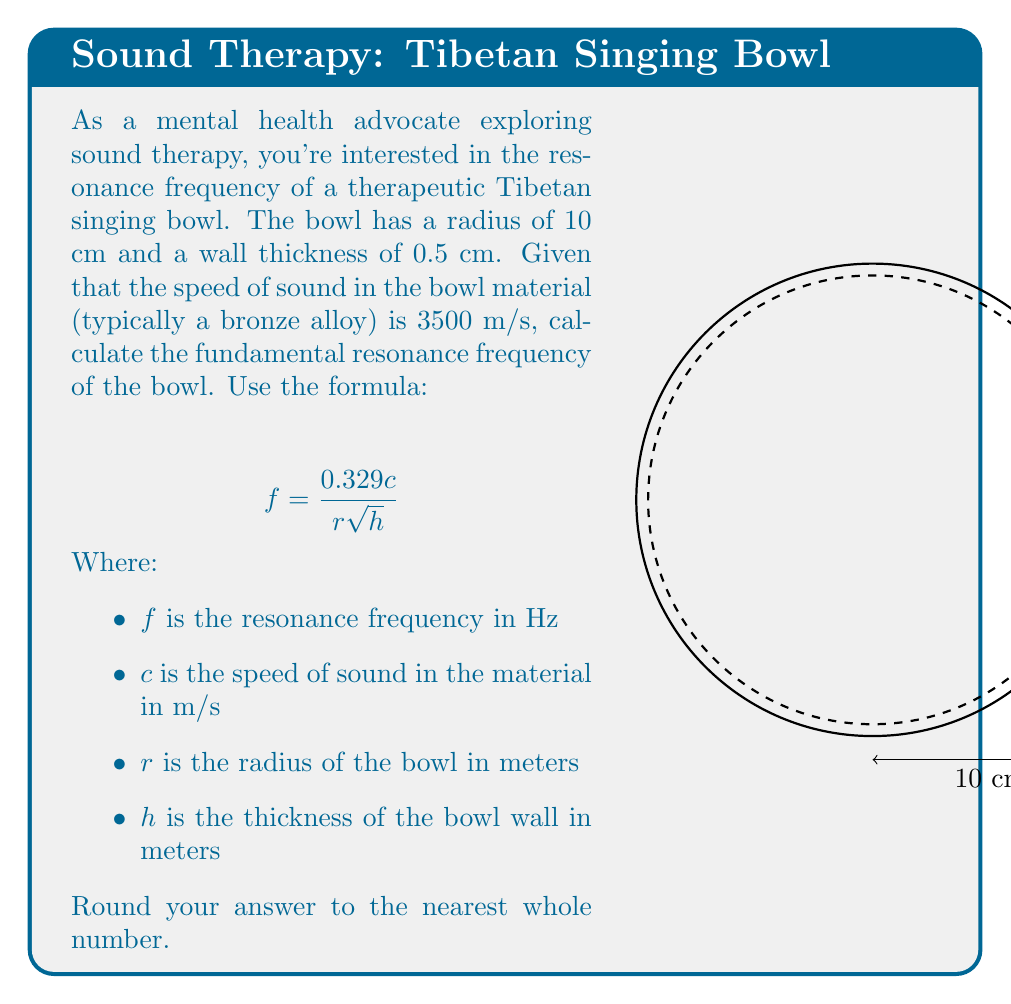Show me your answer to this math problem. Let's approach this step-by-step:

1) First, we need to convert our measurements to meters:
   $r = 10 \text{ cm} = 0.1 \text{ m}$
   $h = 0.5 \text{ cm} = 0.005 \text{ m}$

2) We're given that $c = 3500 \text{ m/s}$

3) Now, let's substitute these values into our formula:

   $$f = \frac{0.329c}{r\sqrt{h}}$$

   $$f = \frac{0.329 \times 3500}{0.1 \times \sqrt{0.005}}$$

4) Let's solve the square root first:
   $\sqrt{0.005} \approx 0.0707$

5) Now our equation looks like this:
   $$f = \frac{0.329 \times 3500}{0.1 \times 0.0707}$$

6) Let's multiply the numerator:
   $$f = \frac{1151.5}{0.00707}$$

7) Finally, let's divide:
   $$f \approx 162870.7$$

8) Rounding to the nearest whole number:
   $$f \approx 162871 \text{ Hz}$$
Answer: $162871 \text{ Hz}$ 